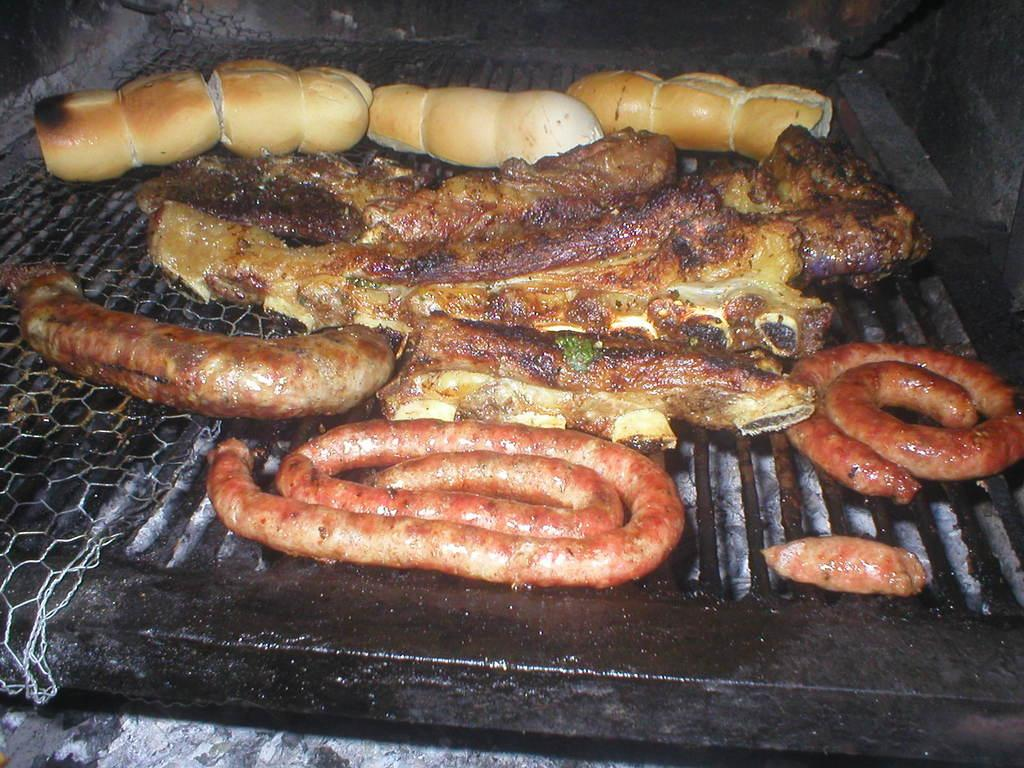What is being cooked in the image? There is food on the grill in the image. What type of ticket is visible in the image? There is no ticket present in the image; it features food on a grill. What kind of creature can be seen interacting with the food on the grill in the image? There is no creature present in the image; it only shows food on a grill. 